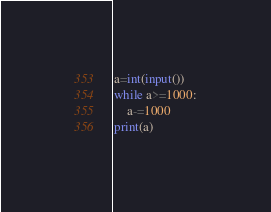<code> <loc_0><loc_0><loc_500><loc_500><_Python_>a=int(input())
while a>=1000:
    a-=1000
print(a)</code> 